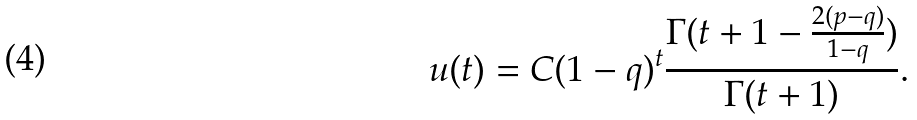<formula> <loc_0><loc_0><loc_500><loc_500>u ( t ) = C ( 1 - q ) ^ { t } \frac { \Gamma ( t + 1 - \frac { 2 ( p - q ) } { 1 - q } ) } { \Gamma ( t + 1 ) } .</formula> 